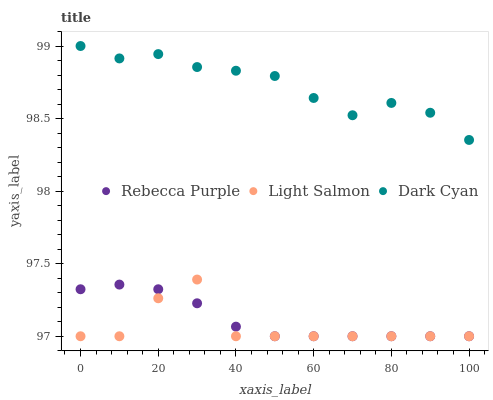Does Light Salmon have the minimum area under the curve?
Answer yes or no. Yes. Does Dark Cyan have the maximum area under the curve?
Answer yes or no. Yes. Does Rebecca Purple have the minimum area under the curve?
Answer yes or no. No. Does Rebecca Purple have the maximum area under the curve?
Answer yes or no. No. Is Rebecca Purple the smoothest?
Answer yes or no. Yes. Is Light Salmon the roughest?
Answer yes or no. Yes. Is Light Salmon the smoothest?
Answer yes or no. No. Is Rebecca Purple the roughest?
Answer yes or no. No. Does Light Salmon have the lowest value?
Answer yes or no. Yes. Does Dark Cyan have the highest value?
Answer yes or no. Yes. Does Light Salmon have the highest value?
Answer yes or no. No. Is Rebecca Purple less than Dark Cyan?
Answer yes or no. Yes. Is Dark Cyan greater than Rebecca Purple?
Answer yes or no. Yes. Does Light Salmon intersect Rebecca Purple?
Answer yes or no. Yes. Is Light Salmon less than Rebecca Purple?
Answer yes or no. No. Is Light Salmon greater than Rebecca Purple?
Answer yes or no. No. Does Rebecca Purple intersect Dark Cyan?
Answer yes or no. No. 